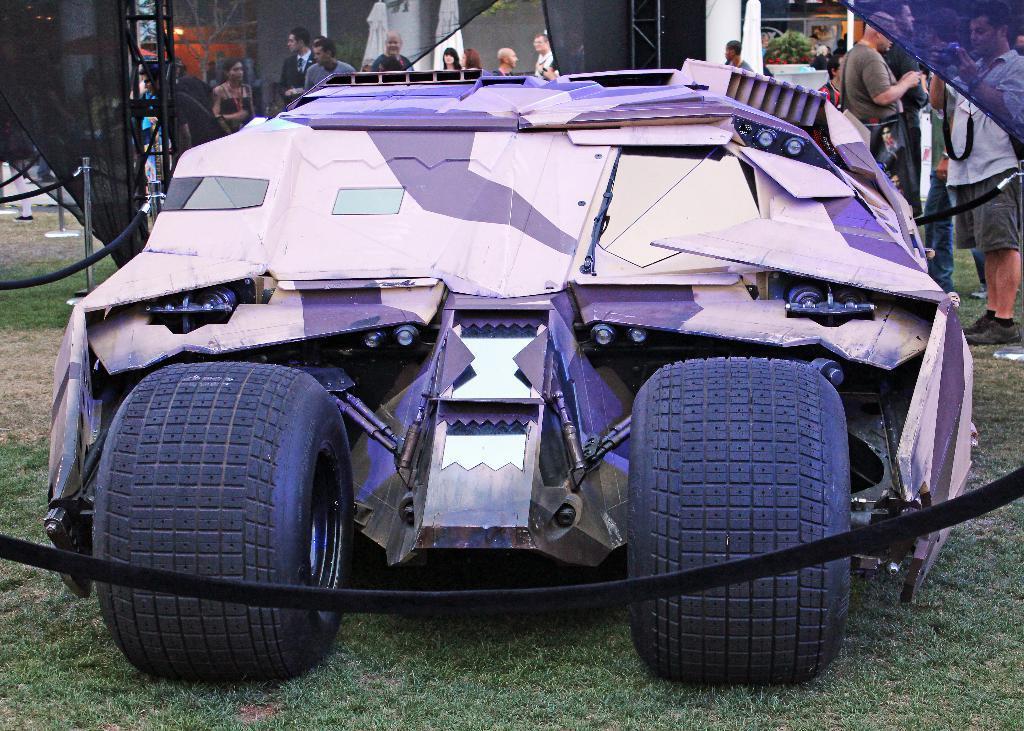Describe this image in one or two sentences. In this picture we can observe a vehicle which is in purple and violet color. We can observe black color tires. There are some people standing beside the vehicle. In the background we can observe some people. 